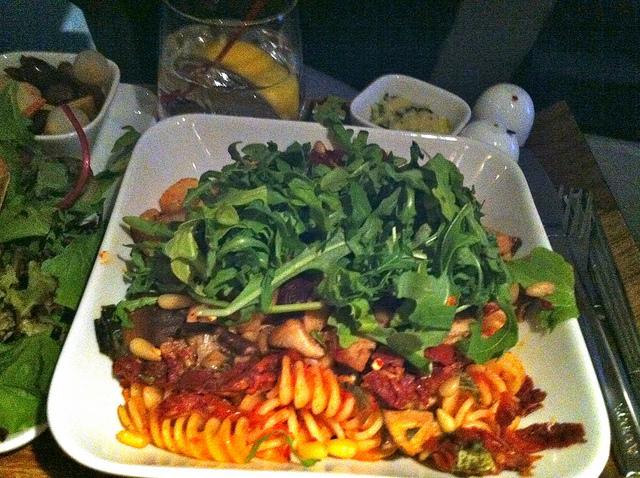Is this pasta?
Write a very short answer. Yes. How many different kinds of lettuce on the plate?
Give a very brief answer. 1. Does this meal contain any carbohydrate rich foods?
Answer briefly. Yes. Is there any greenery on the plate?
Be succinct. Yes. 